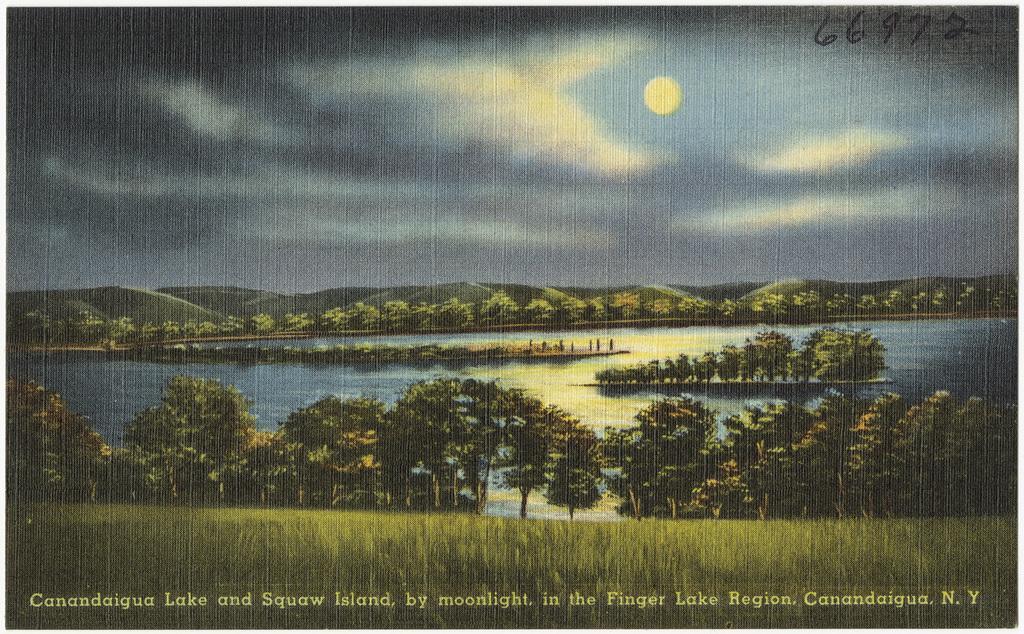Could you give a brief overview of what you see in this image? In the image we can see a painting. In the painting, we can see there are many trees, hills, grass, water, cloudy sky and a moon. 